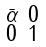Convert formula to latex. <formula><loc_0><loc_0><loc_500><loc_500>\begin{smallmatrix} \bar { \alpha } & 0 \\ 0 & 1 \end{smallmatrix}</formula> 